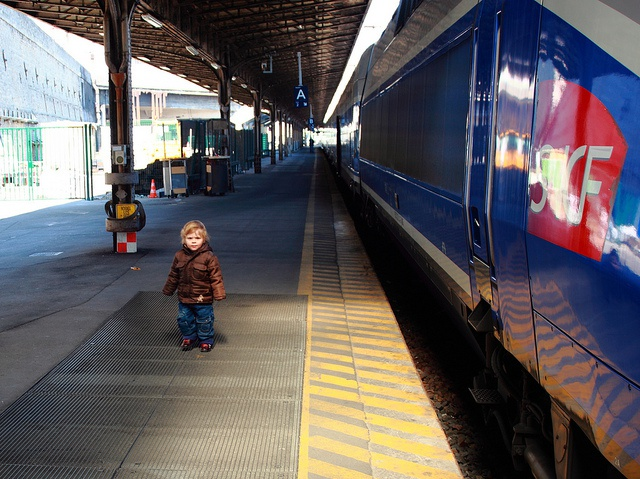Describe the objects in this image and their specific colors. I can see train in black, navy, gray, and darkgray tones, people in black, maroon, navy, and brown tones, and people in black, navy, gray, and green tones in this image. 